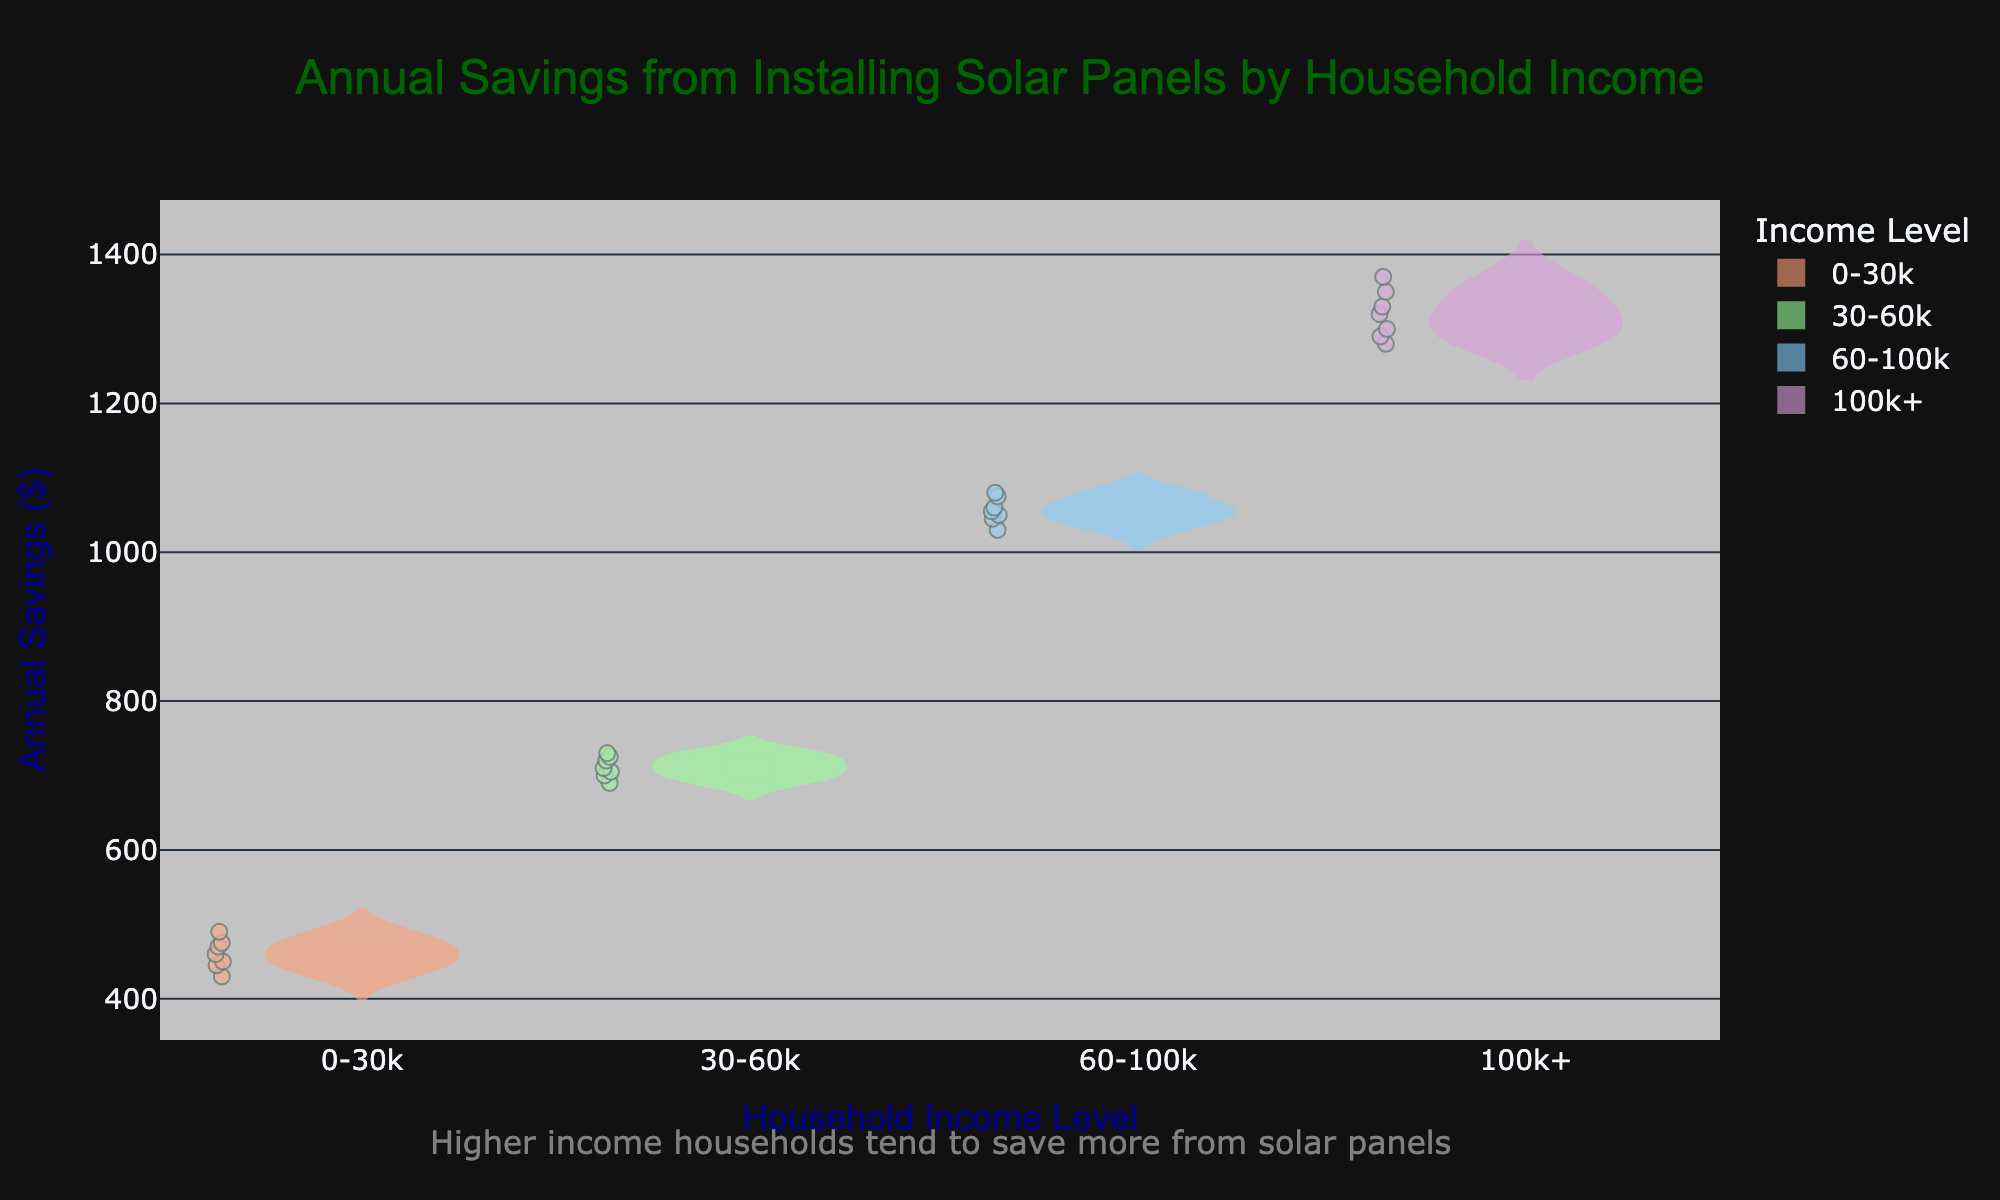What is the title of the figure? The title is prominently displayed at the top of the figure and reads "Annual Savings from Installing Solar Panels by Household Income."
Answer: Annual Savings from Installing Solar Panels by Household Income How many household income levels are represented in the figure? By looking at the x-axis categories, there are four unique household income levels represented.
Answer: 4 Which household income level has the highest median annual savings? Median values are indicated by the line inside each box. The "100k+" income level has the line positioned at the highest value compared to other income levels.
Answer: 100k+ What is the approximate median annual savings for the "30-60k" income level? The median is the middle value of the box visible inside the violin plot for the "30-60k" income level, approximately reading around 710 dollars.
Answer: 710 What is the range of annual savings for the "0-30k" income level? The range can be observed by the span of the violin plot for the "0-30k" income level; it roughly appears to be from 430 to 490 dollars.
Answer: 430 to 490 Which income level shows the highest variation in the annual savings? The width of the violin plots indicates distribution density, and the "100k+" income level spans the widest range of values indicating the highest variation.
Answer: 100k+ Do higher income households tend to save more from installing solar panels? The higher household income levels ("60-100k" and "100k+") show higher positions on the y-axis for savings, indicating higher savings compared to lower income levels.
Answer: Yes Are there outliers present in the "30-60k" income level? Outliers in violin plots are typically marked beyond the whiskers of the box plot, and no distinct points seem scattered outside this range for "30-60k."
Answer: No 